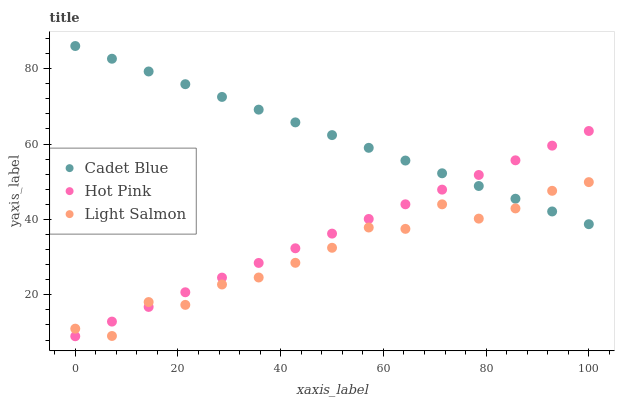Does Light Salmon have the minimum area under the curve?
Answer yes or no. Yes. Does Cadet Blue have the maximum area under the curve?
Answer yes or no. Yes. Does Hot Pink have the minimum area under the curve?
Answer yes or no. No. Does Hot Pink have the maximum area under the curve?
Answer yes or no. No. Is Cadet Blue the smoothest?
Answer yes or no. Yes. Is Light Salmon the roughest?
Answer yes or no. Yes. Is Hot Pink the smoothest?
Answer yes or no. No. Is Hot Pink the roughest?
Answer yes or no. No. Does Hot Pink have the lowest value?
Answer yes or no. Yes. Does Cadet Blue have the lowest value?
Answer yes or no. No. Does Cadet Blue have the highest value?
Answer yes or no. Yes. Does Hot Pink have the highest value?
Answer yes or no. No. Does Light Salmon intersect Cadet Blue?
Answer yes or no. Yes. Is Light Salmon less than Cadet Blue?
Answer yes or no. No. Is Light Salmon greater than Cadet Blue?
Answer yes or no. No. 